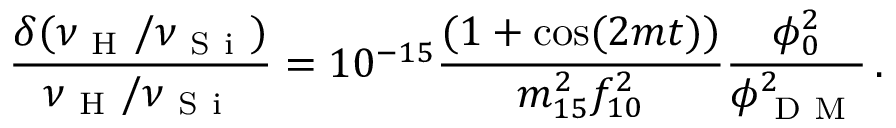Convert formula to latex. <formula><loc_0><loc_0><loc_500><loc_500>\frac { \delta ( \nu _ { H } / \nu _ { S i } ) } { \nu _ { H } / \nu _ { S i } } = 1 0 ^ { - 1 5 } \frac { ( 1 + \cos ( 2 m t ) ) } { m _ { 1 5 } ^ { 2 } f _ { 1 0 } ^ { 2 } } \frac { \phi _ { 0 } ^ { 2 } } { \phi _ { D M } ^ { 2 } } \, .</formula> 